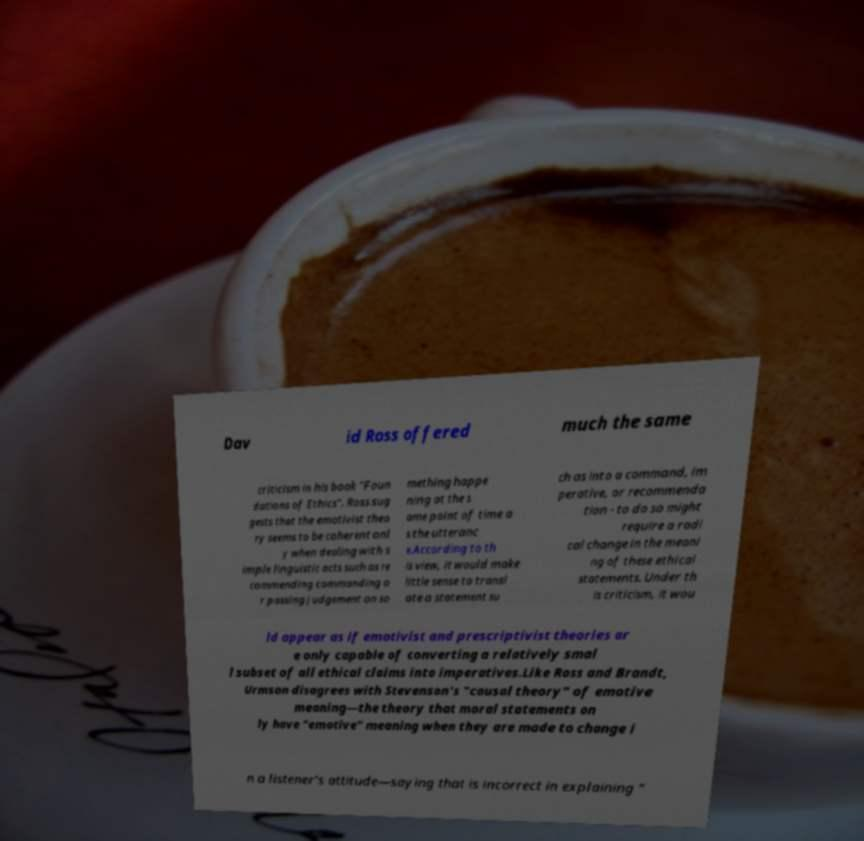Can you accurately transcribe the text from the provided image for me? Dav id Ross offered much the same criticism in his book "Foun dations of Ethics". Ross sug gests that the emotivist theo ry seems to be coherent onl y when dealing with s imple linguistic acts such as re commending commanding o r passing judgement on so mething happe ning at the s ame point of time a s the utteranc e.According to th is view, it would make little sense to transl ate a statement su ch as into a command, im perative, or recommenda tion - to do so might require a radi cal change in the meani ng of these ethical statements. Under th is criticism, it wou ld appear as if emotivist and prescriptivist theories ar e only capable of converting a relatively smal l subset of all ethical claims into imperatives.Like Ross and Brandt, Urmson disagrees with Stevenson's "causal theory" of emotive meaning—the theory that moral statements on ly have "emotive" meaning when they are made to change i n a listener's attitude—saying that is incorrect in explaining " 